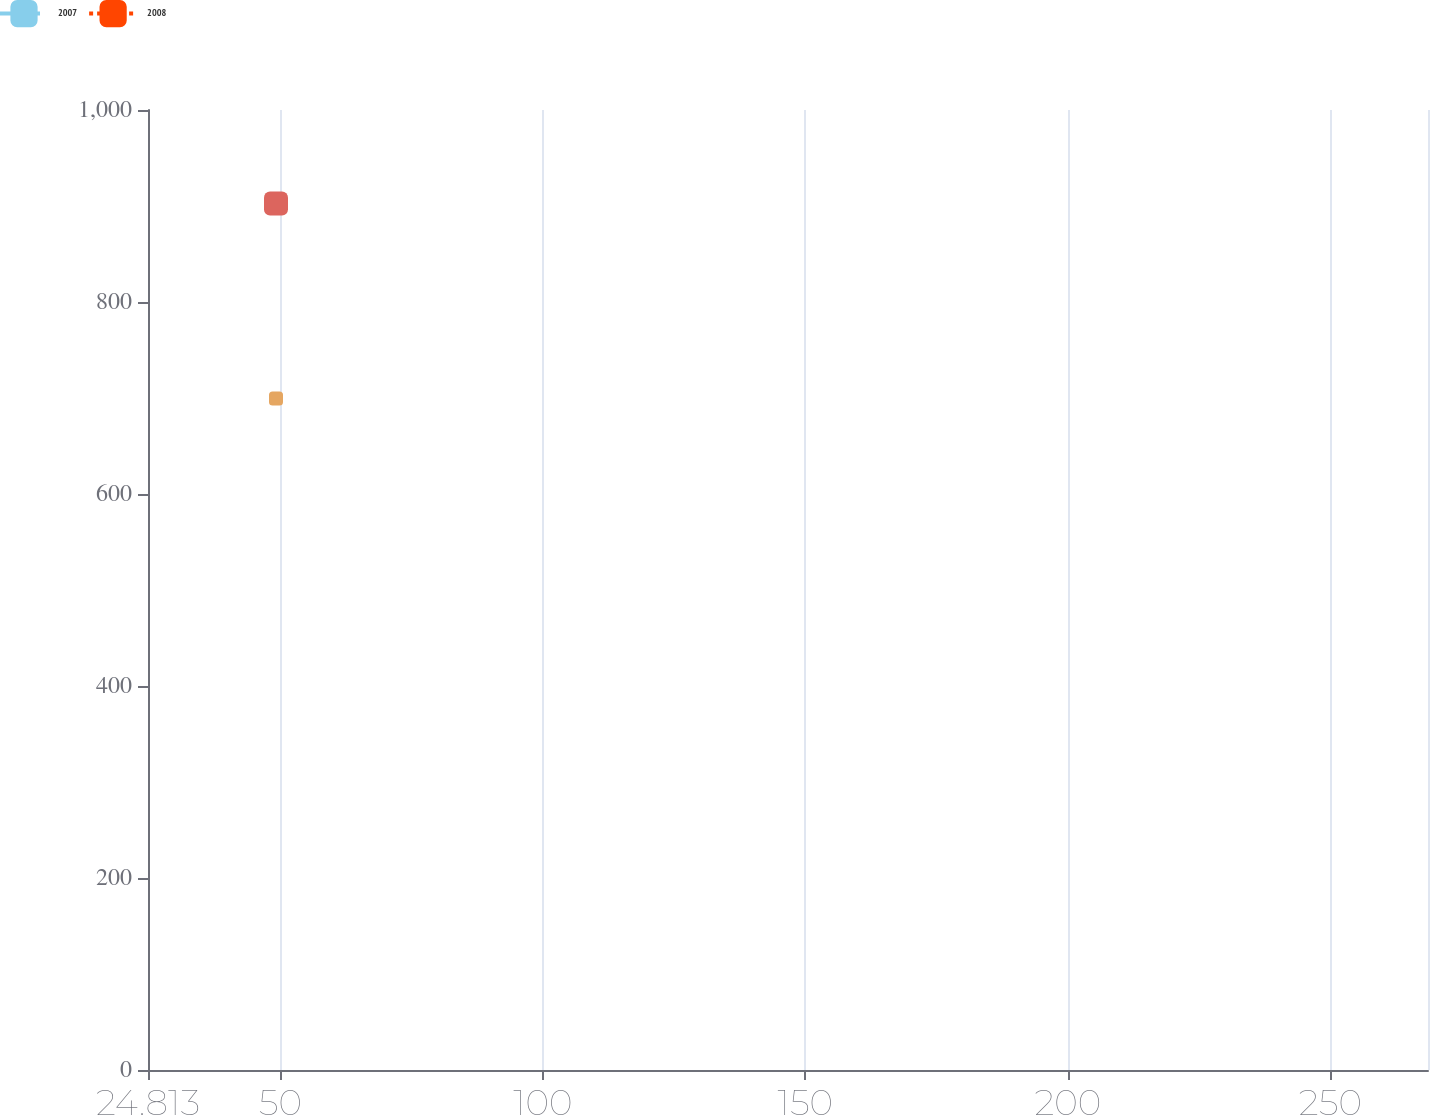Convert chart to OTSL. <chart><loc_0><loc_0><loc_500><loc_500><line_chart><ecel><fcel>2007<fcel>2008<nl><fcel>49.19<fcel>699.41<fcel>902.49<nl><fcel>269.81<fcel>390.43<fcel>215.91<nl><fcel>292.96<fcel>941.69<fcel>975.69<nl></chart> 